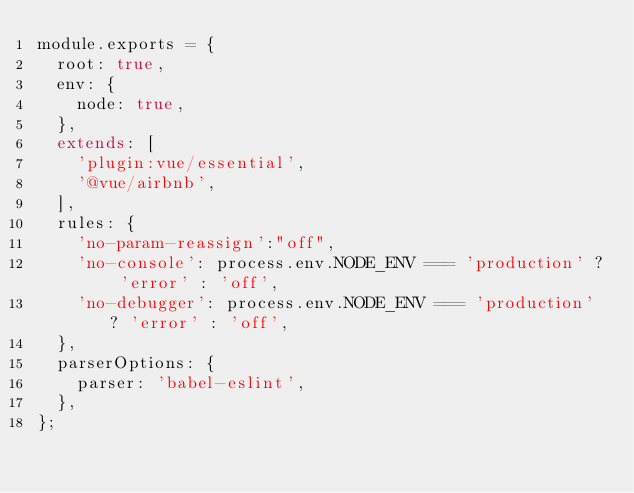Convert code to text. <code><loc_0><loc_0><loc_500><loc_500><_JavaScript_>module.exports = {
  root: true,
  env: {
    node: true,
  },
  extends: [
    'plugin:vue/essential',
    '@vue/airbnb',
  ],
  rules: {
    'no-param-reassign':"off",
    'no-console': process.env.NODE_ENV === 'production' ? 'error' : 'off',
    'no-debugger': process.env.NODE_ENV === 'production' ? 'error' : 'off',
  },
  parserOptions: {
    parser: 'babel-eslint',
  },
};
</code> 